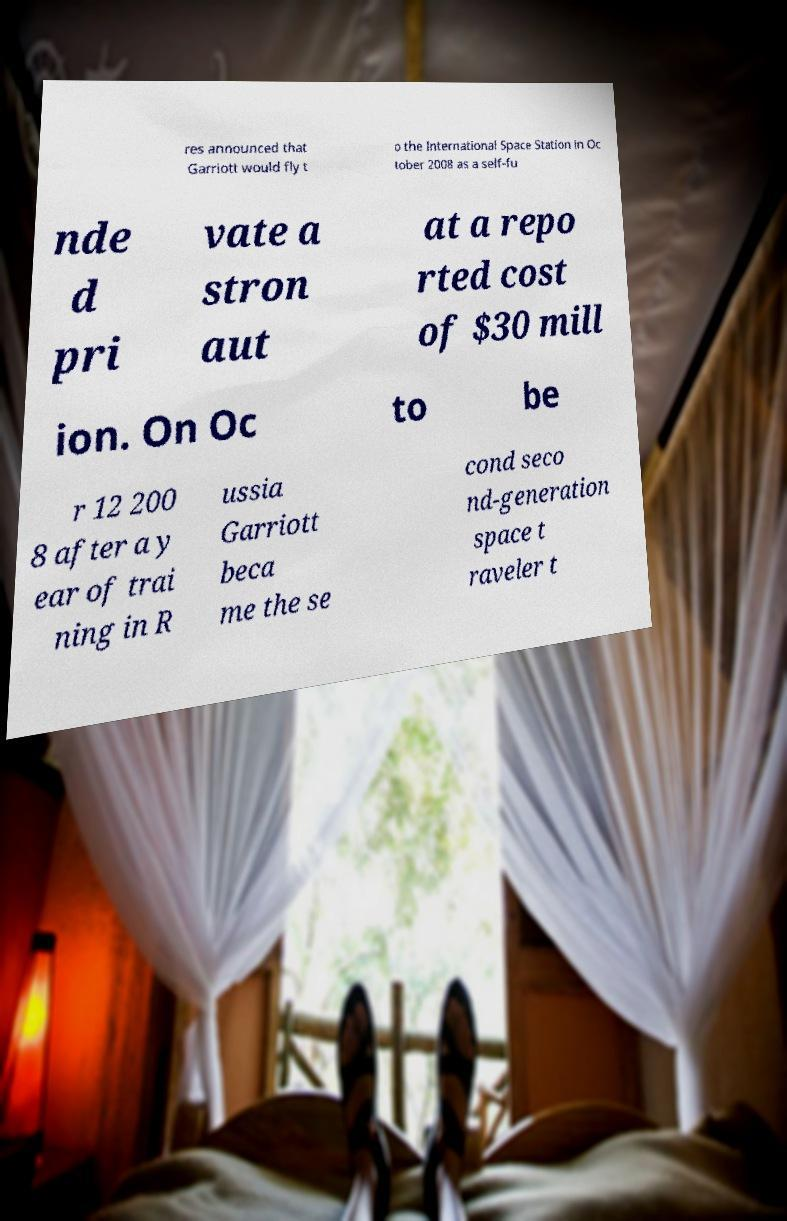Could you extract and type out the text from this image? res announced that Garriott would fly t o the International Space Station in Oc tober 2008 as a self-fu nde d pri vate a stron aut at a repo rted cost of $30 mill ion. On Oc to be r 12 200 8 after a y ear of trai ning in R ussia Garriott beca me the se cond seco nd-generation space t raveler t 